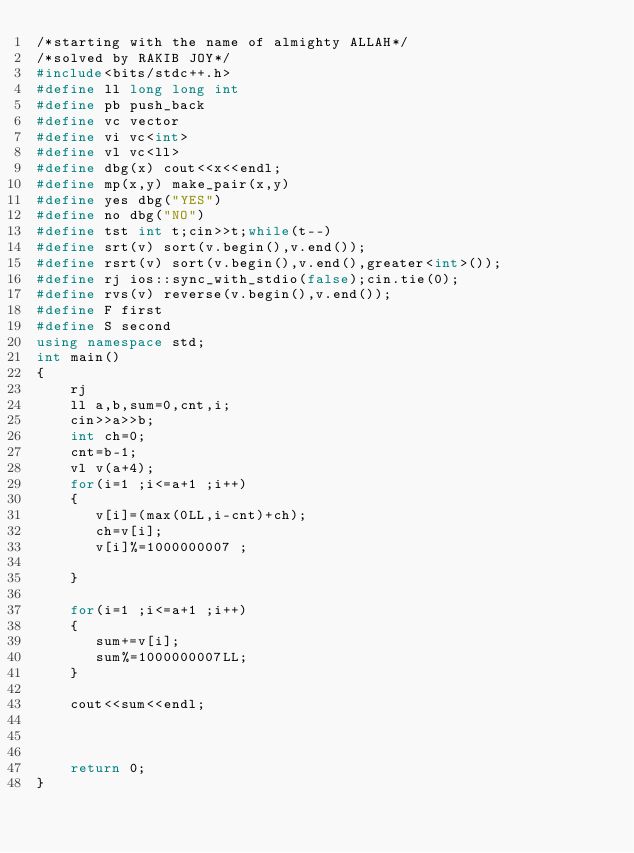<code> <loc_0><loc_0><loc_500><loc_500><_C++_>/*starting with the name of almighty ALLAH*/
/*solved by RAKIB JOY*/
#include<bits/stdc++.h>
#define ll long long int
#define pb push_back
#define vc vector
#define vi vc<int>
#define vl vc<ll>
#define dbg(x) cout<<x<<endl;
#define mp(x,y) make_pair(x,y)
#define yes dbg("YES")
#define no dbg("NO")
#define tst int t;cin>>t;while(t--)
#define srt(v) sort(v.begin(),v.end());
#define rsrt(v) sort(v.begin(),v.end(),greater<int>());
#define rj ios::sync_with_stdio(false);cin.tie(0);
#define rvs(v) reverse(v.begin(),v.end());
#define F first
#define S second
using namespace std;
int main()
{
    rj
    ll a,b,sum=0,cnt,i;
    cin>>a>>b;
    int ch=0;
    cnt=b-1;
    vl v(a+4);
    for(i=1 ;i<=a+1 ;i++)
    {
       v[i]=(max(0LL,i-cnt)+ch);
       ch=v[i];
       v[i]%=1000000007 ;

    }

    for(i=1 ;i<=a+1 ;i++)
    {
       sum+=v[i];
       sum%=1000000007LL;
    }

    cout<<sum<<endl;



    return 0;
}

</code> 